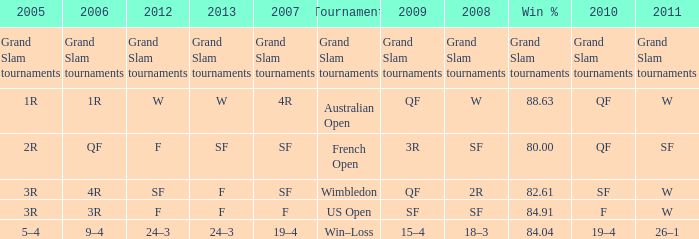WHat in 2005 has a Win % of 82.61? 3R. 